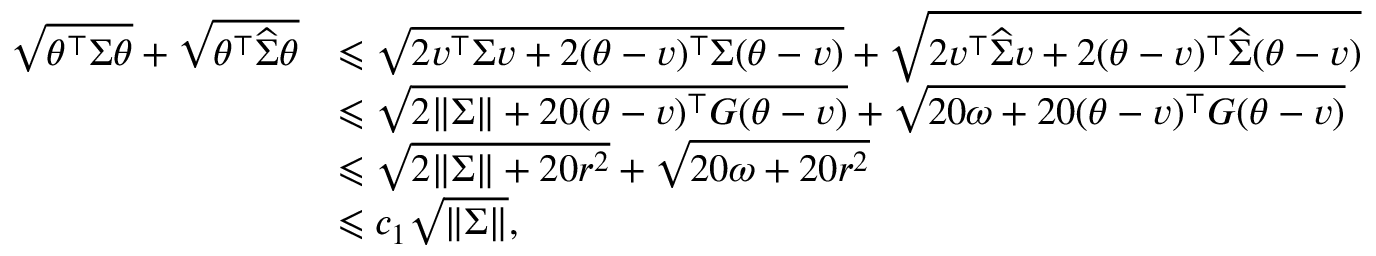<formula> <loc_0><loc_0><loc_500><loc_500>\begin{array} { r l } { \sqrt { \theta ^ { \top } { \Sigma } \theta } + \sqrt { \theta ^ { \top } \widehat { \Sigma } \theta } } & { \leqslant \sqrt { 2 v ^ { \top } { \Sigma } v + 2 ( \theta - v ) ^ { \top } { \Sigma } ( \theta - v ) } + \sqrt { 2 v ^ { \top } \widehat { \Sigma } v + 2 ( \theta - v ) ^ { \top } \widehat { \Sigma } ( \theta - v ) } } \\ & { \leqslant \sqrt { 2 \| \Sigma \| + 2 0 ( \theta - v ) ^ { \top } { G } ( \theta - v ) } + \sqrt { 2 0 \omega + 2 0 ( \theta - v ) ^ { \top } G ( \theta - v ) } } \\ & { \leqslant \sqrt { 2 \| \Sigma \| + 2 0 r ^ { 2 } } + \sqrt { 2 0 \omega + 2 0 r ^ { 2 } } } \\ & { \leqslant c _ { 1 } \sqrt { \| \Sigma \| } , } \end{array}</formula> 